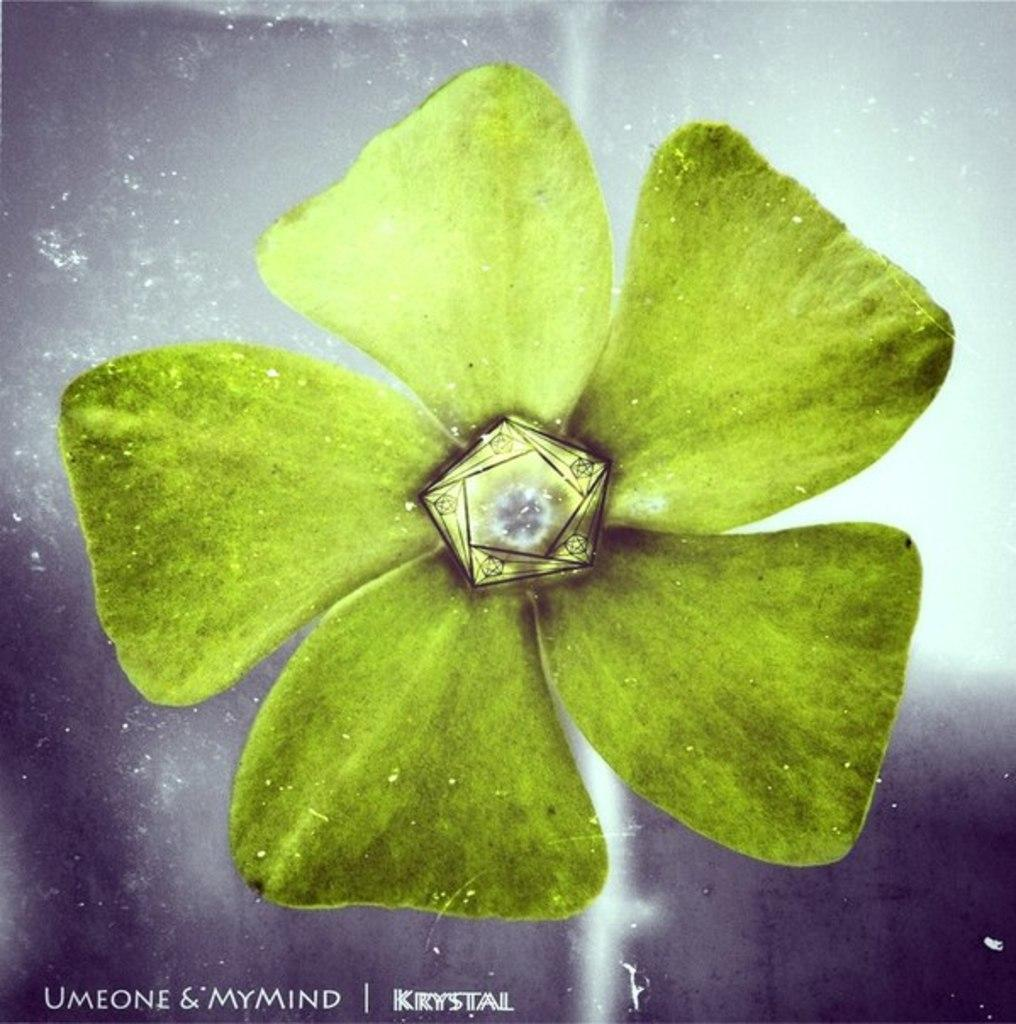What type of flower is present in the image? There is a green color flower in the image. Can you describe any unique features of the flower? Yes, there is a pearl on the flower. How does the plough help the friend in the image? There is no plough or friend present in the image; it only features a green color flower with a pearl on it. 